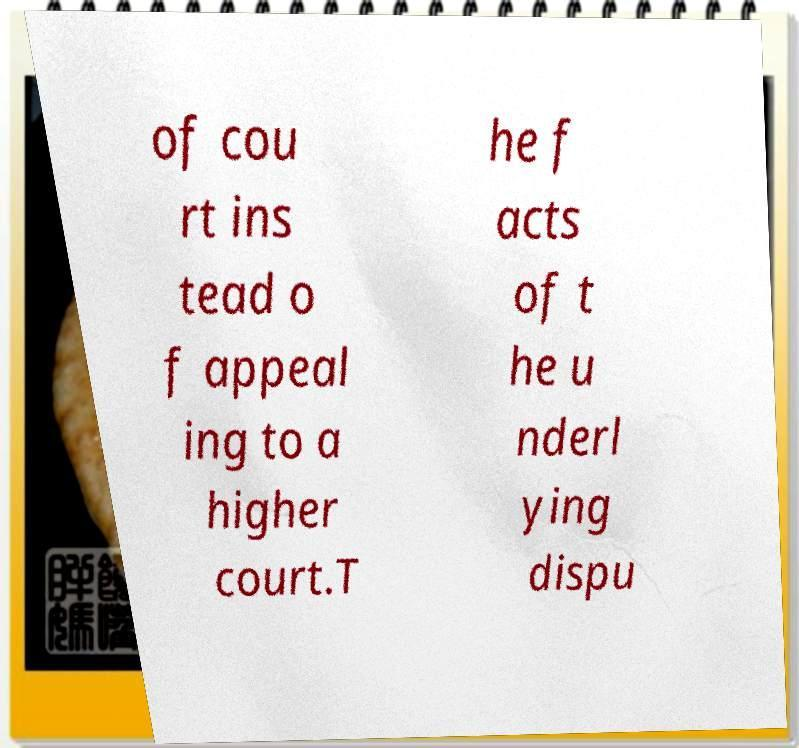There's text embedded in this image that I need extracted. Can you transcribe it verbatim? of cou rt ins tead o f appeal ing to a higher court.T he f acts of t he u nderl ying dispu 